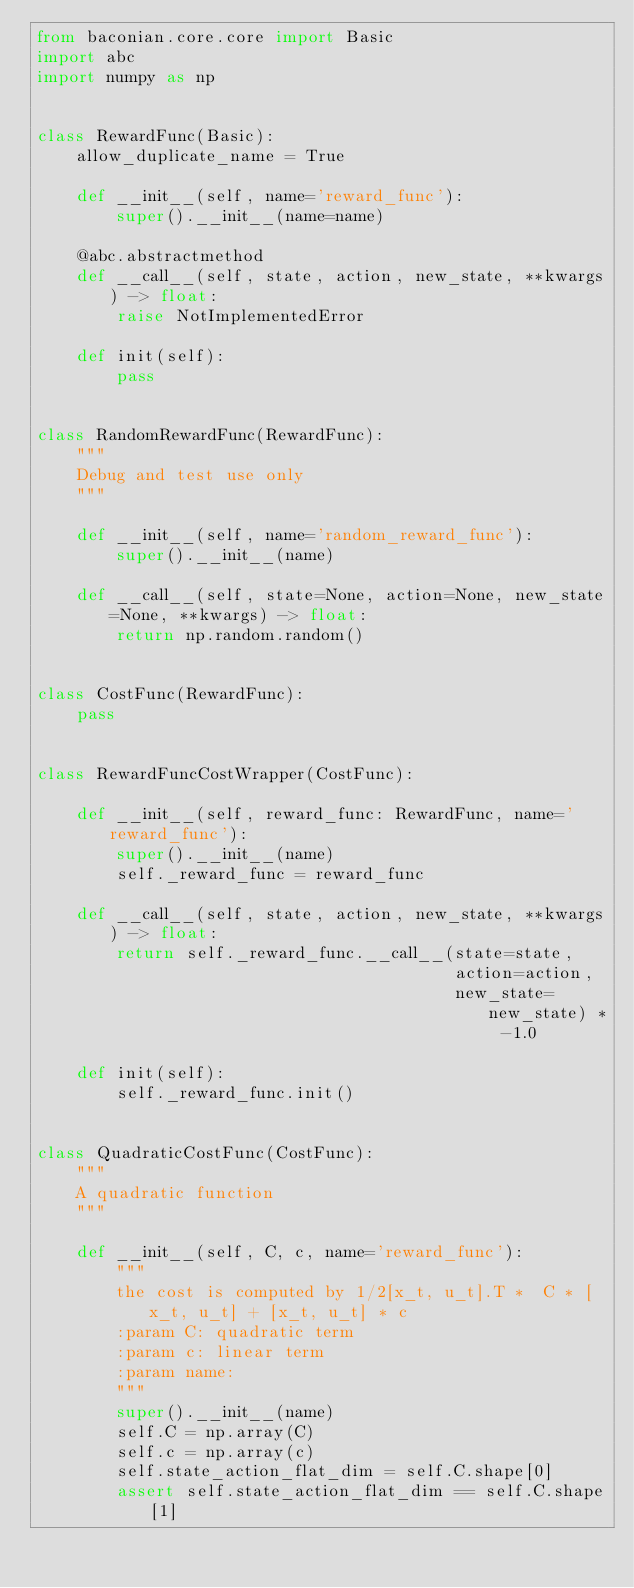Convert code to text. <code><loc_0><loc_0><loc_500><loc_500><_Python_>from baconian.core.core import Basic
import abc
import numpy as np


class RewardFunc(Basic):
    allow_duplicate_name = True

    def __init__(self, name='reward_func'):
        super().__init__(name=name)

    @abc.abstractmethod
    def __call__(self, state, action, new_state, **kwargs) -> float:
        raise NotImplementedError

    def init(self):
        pass


class RandomRewardFunc(RewardFunc):
    """
    Debug and test use only
    """

    def __init__(self, name='random_reward_func'):
        super().__init__(name)

    def __call__(self, state=None, action=None, new_state=None, **kwargs) -> float:
        return np.random.random()


class CostFunc(RewardFunc):
    pass


class RewardFuncCostWrapper(CostFunc):

    def __init__(self, reward_func: RewardFunc, name='reward_func'):
        super().__init__(name)
        self._reward_func = reward_func

    def __call__(self, state, action, new_state, **kwargs) -> float:
        return self._reward_func.__call__(state=state,
                                          action=action,
                                          new_state=new_state) * -1.0

    def init(self):
        self._reward_func.init()


class QuadraticCostFunc(CostFunc):
    """
    A quadratic function
    """

    def __init__(self, C, c, name='reward_func'):
        """
        the cost is computed by 1/2[x_t, u_t].T *  C * [x_t, u_t] + [x_t, u_t] * c
        :param C: quadratic term
        :param c: linear term
        :param name:
        """
        super().__init__(name)
        self.C = np.array(C)
        self.c = np.array(c)
        self.state_action_flat_dim = self.C.shape[0]
        assert self.state_action_flat_dim == self.C.shape[1]</code> 